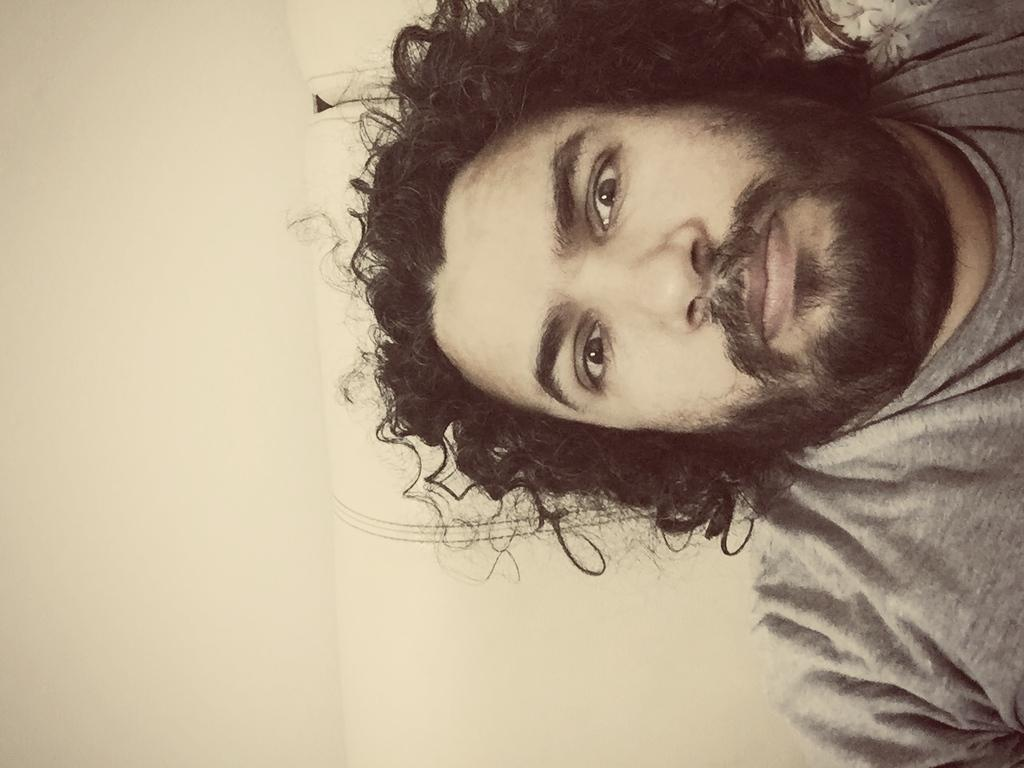What is present in the image? There is a person in the image. What is the person wearing? The person is wearing an ash-colored T-shirt. Where is the person located in the image? The person is in the right corner of the image. What type of sack can be seen in the image? There is no sack present in the image. What kind of art is displayed on the wall behind the person? The facts provided do not mention any art on the wall behind the person. 